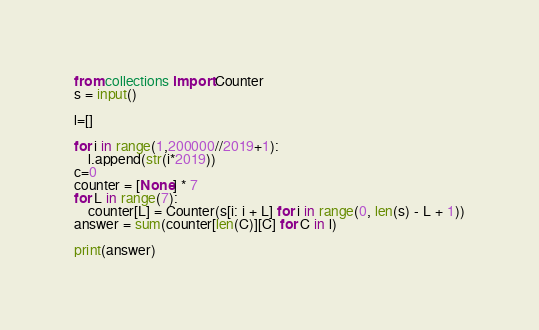<code> <loc_0><loc_0><loc_500><loc_500><_Python_>from collections import Counter
s = input()

l=[]

for i in range(1,200000//2019+1):
    l.append(str(i*2019))
c=0
counter = [None] * 7
for L in range(7):
    counter[L] = Counter(s[i: i + L] for i in range(0, len(s) - L + 1))
answer = sum(counter[len(C)][C] for C in l)

print(answer)</code> 